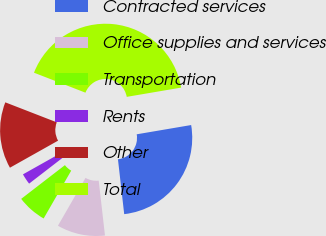Convert chart to OTSL. <chart><loc_0><loc_0><loc_500><loc_500><pie_chart><fcel>Contracted services<fcel>Office supplies and services<fcel>Transportation<fcel>Rents<fcel>Other<fcel>Total<nl><fcel>25.87%<fcel>10.13%<fcel>6.22%<fcel>2.31%<fcel>14.04%<fcel>41.42%<nl></chart> 